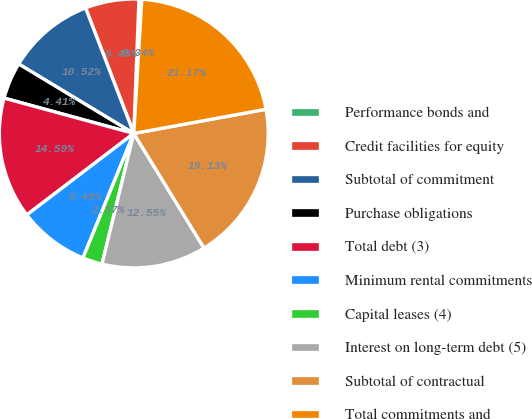<chart> <loc_0><loc_0><loc_500><loc_500><pie_chart><fcel>Performance bonds and<fcel>Credit facilities for equity<fcel>Subtotal of commitment<fcel>Purchase obligations<fcel>Total debt (3)<fcel>Minimum rental commitments<fcel>Capital leases (4)<fcel>Interest on long-term debt (5)<fcel>Subtotal of contractual<fcel>Total commitments and<nl><fcel>0.34%<fcel>6.45%<fcel>10.52%<fcel>4.41%<fcel>14.59%<fcel>8.48%<fcel>2.37%<fcel>12.55%<fcel>19.13%<fcel>21.17%<nl></chart> 